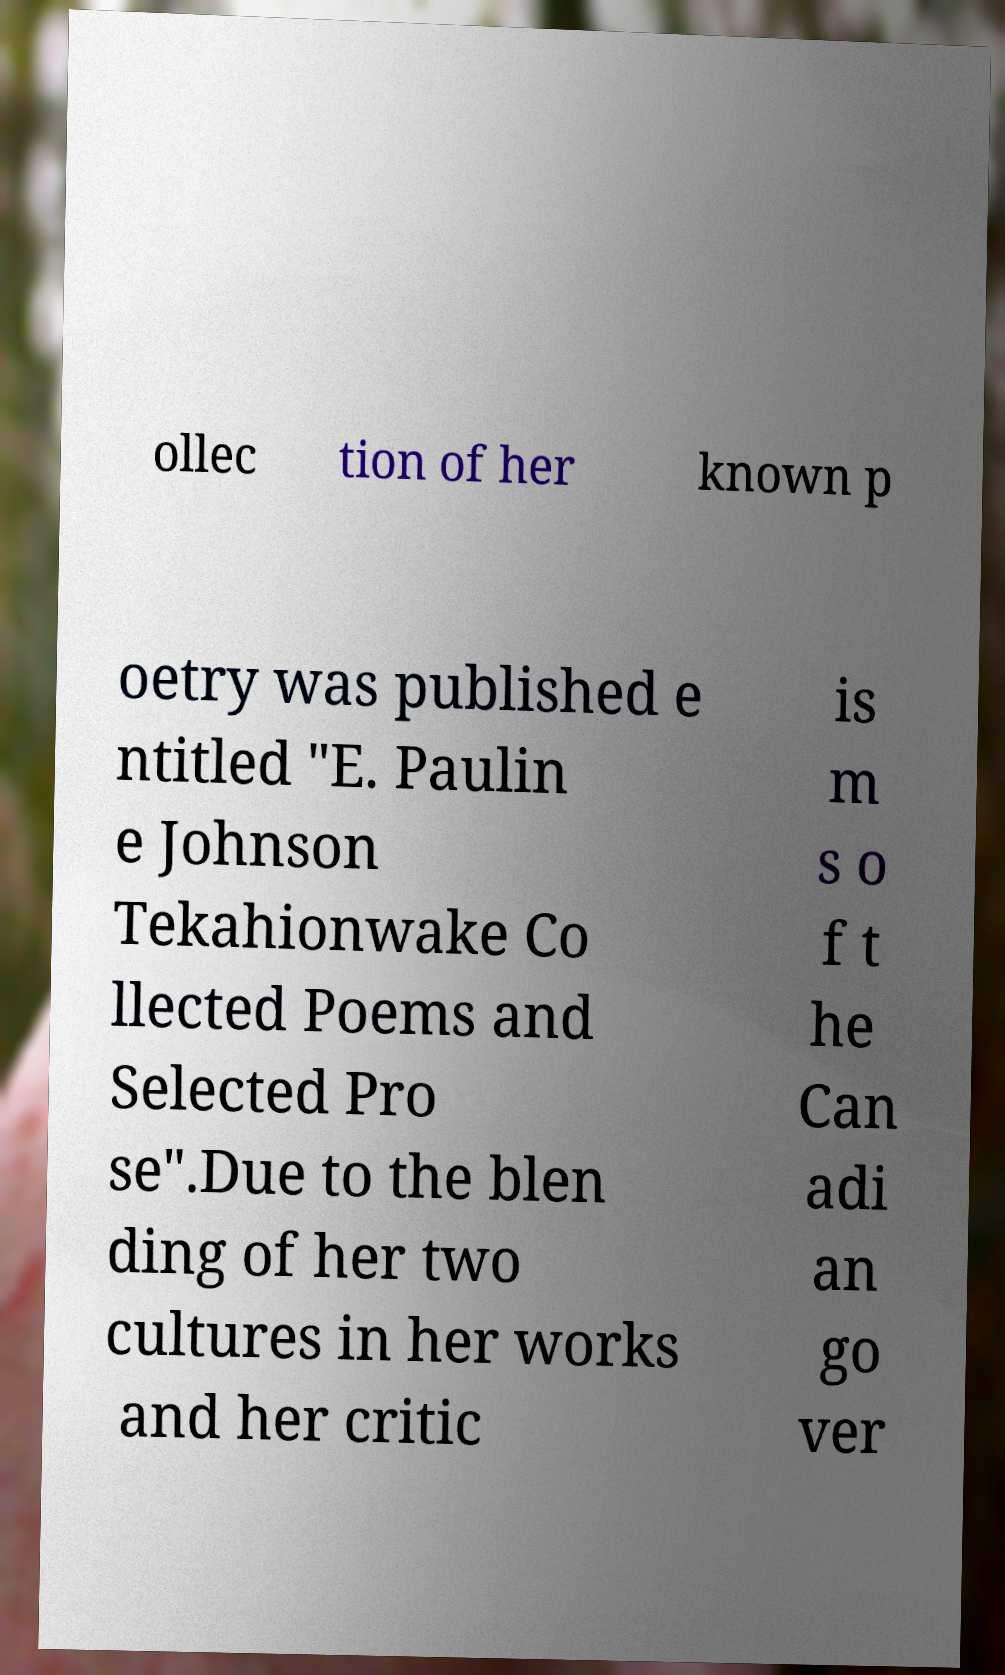Can you read and provide the text displayed in the image?This photo seems to have some interesting text. Can you extract and type it out for me? ollec tion of her known p oetry was published e ntitled "E. Paulin e Johnson Tekahionwake Co llected Poems and Selected Pro se".Due to the blen ding of her two cultures in her works and her critic is m s o f t he Can adi an go ver 